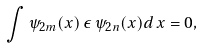<formula> <loc_0><loc_0><loc_500><loc_500>\int \psi _ { 2 m } ( x ) \, \epsilon \, \psi _ { 2 n } ( x ) d \, x = 0 ,</formula> 